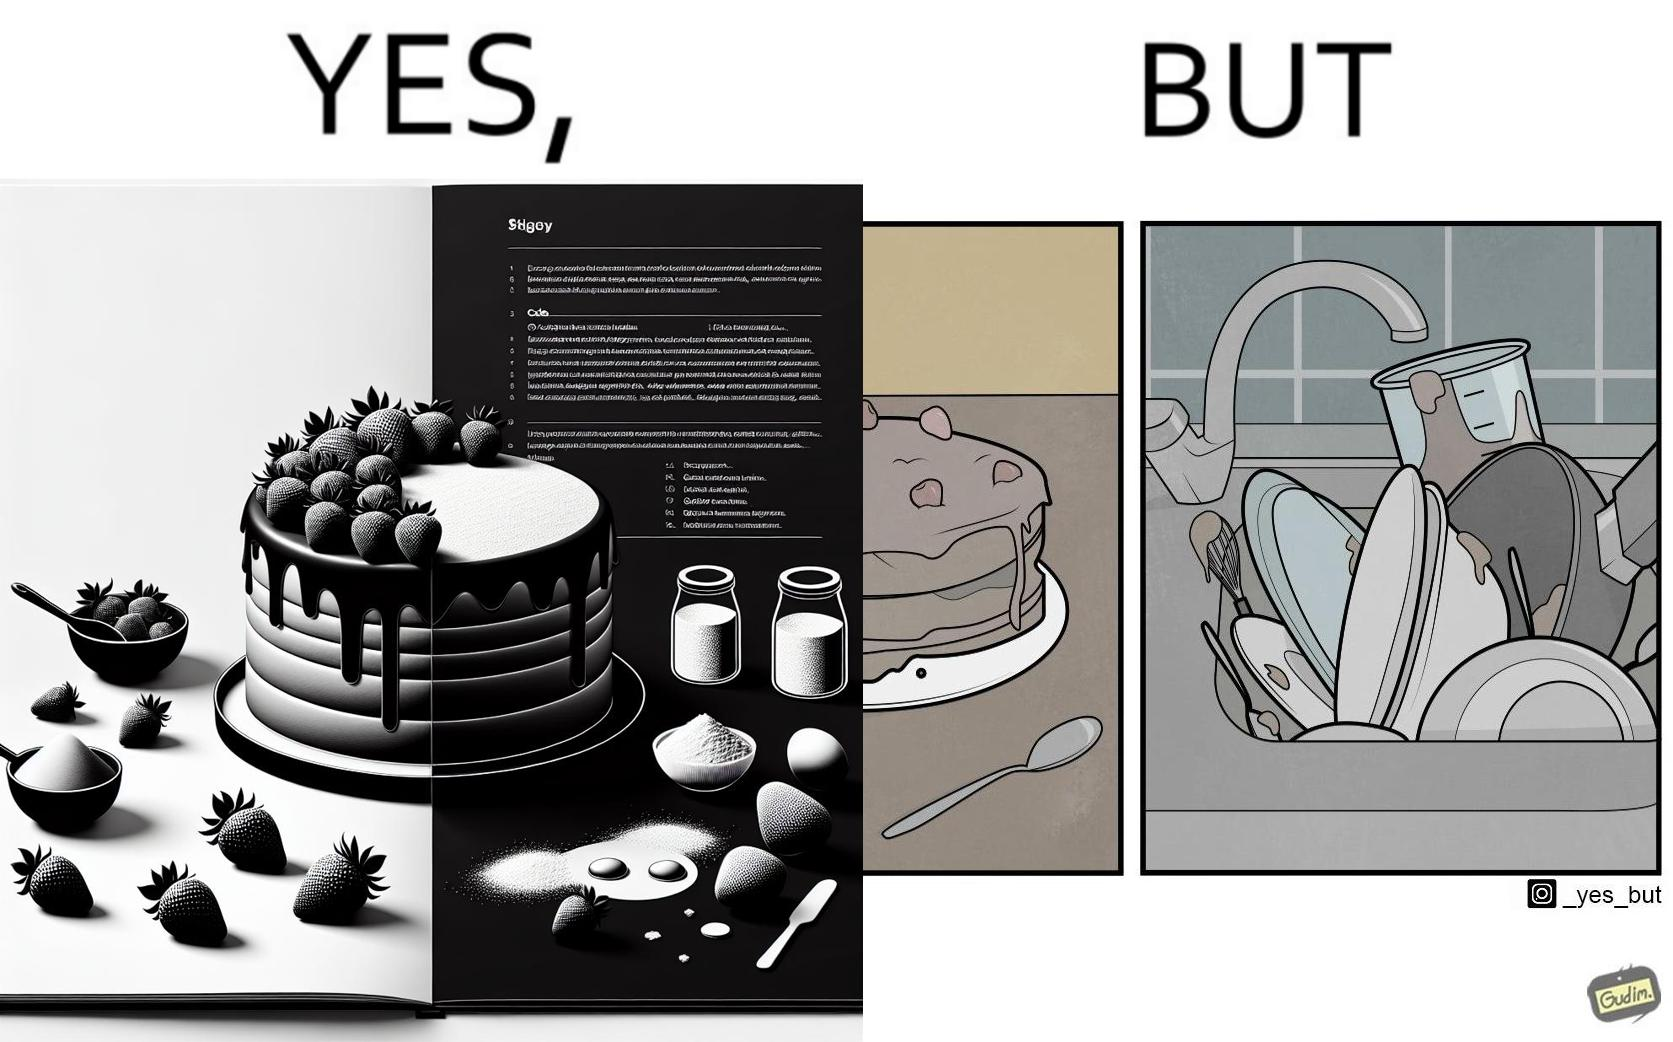Describe the satirical element in this image. The image is funny, as when making a strawberry cake using  a recipe book, the outcome is not quite what is expected, and one has to wash the used utensils afterwards as well. 